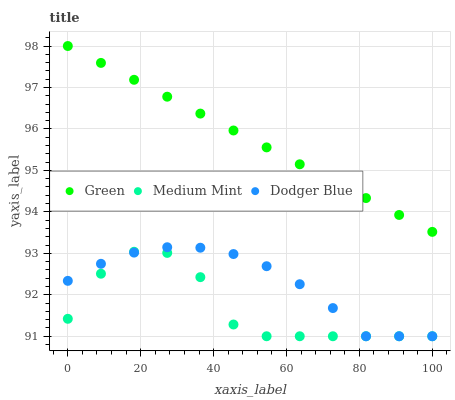Does Medium Mint have the minimum area under the curve?
Answer yes or no. Yes. Does Green have the maximum area under the curve?
Answer yes or no. Yes. Does Dodger Blue have the minimum area under the curve?
Answer yes or no. No. Does Dodger Blue have the maximum area under the curve?
Answer yes or no. No. Is Green the smoothest?
Answer yes or no. Yes. Is Medium Mint the roughest?
Answer yes or no. Yes. Is Dodger Blue the smoothest?
Answer yes or no. No. Is Dodger Blue the roughest?
Answer yes or no. No. Does Medium Mint have the lowest value?
Answer yes or no. Yes. Does Green have the lowest value?
Answer yes or no. No. Does Green have the highest value?
Answer yes or no. Yes. Does Dodger Blue have the highest value?
Answer yes or no. No. Is Medium Mint less than Green?
Answer yes or no. Yes. Is Green greater than Medium Mint?
Answer yes or no. Yes. Does Dodger Blue intersect Medium Mint?
Answer yes or no. Yes. Is Dodger Blue less than Medium Mint?
Answer yes or no. No. Is Dodger Blue greater than Medium Mint?
Answer yes or no. No. Does Medium Mint intersect Green?
Answer yes or no. No. 